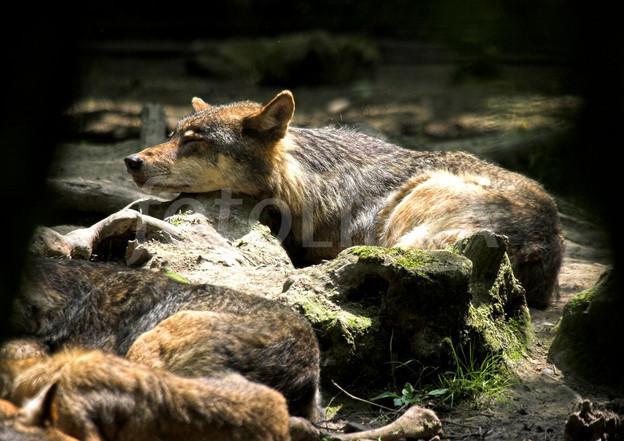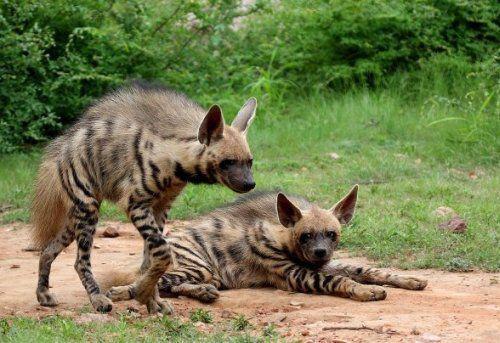The first image is the image on the left, the second image is the image on the right. For the images displayed, is the sentence "At least one hyena is laying down." factually correct? Answer yes or no. Yes. The first image is the image on the left, the second image is the image on the right. Examine the images to the left and right. Is the description "No image contains more than one animal, and one image features an adult hyena in a standing pose with its body turned rightward." accurate? Answer yes or no. No. 